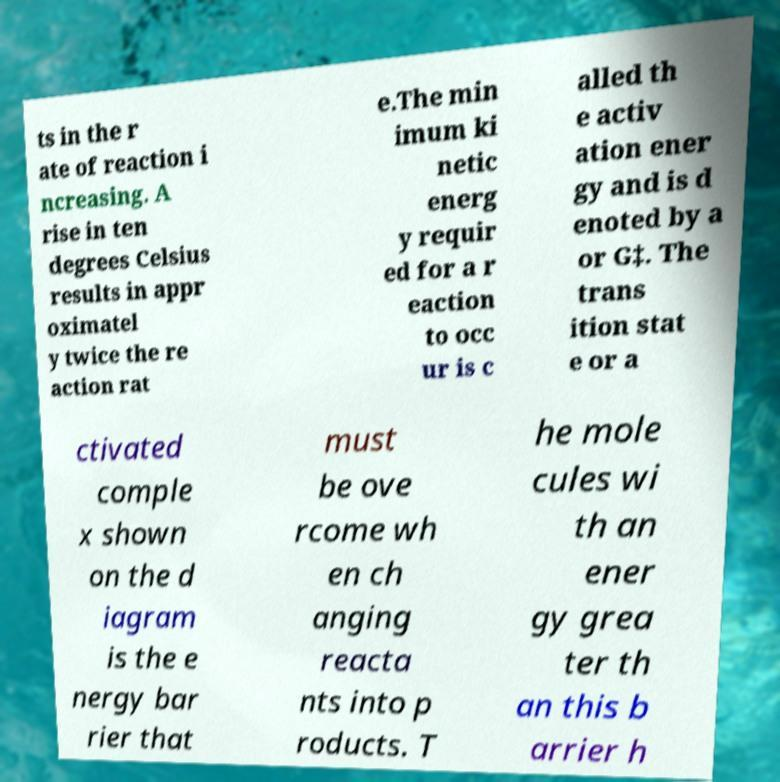There's text embedded in this image that I need extracted. Can you transcribe it verbatim? ts in the r ate of reaction i ncreasing. A rise in ten degrees Celsius results in appr oximatel y twice the re action rat e.The min imum ki netic energ y requir ed for a r eaction to occ ur is c alled th e activ ation ener gy and is d enoted by a or G‡. The trans ition stat e or a ctivated comple x shown on the d iagram is the e nergy bar rier that must be ove rcome wh en ch anging reacta nts into p roducts. T he mole cules wi th an ener gy grea ter th an this b arrier h 